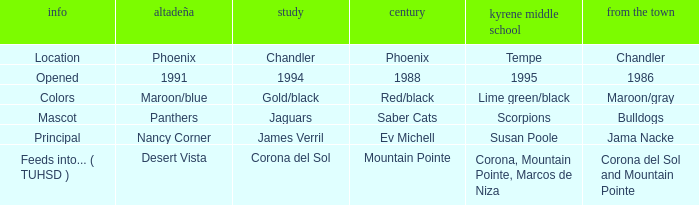Which Altadeña has a Aprende of jaguars? Panthers. 